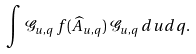Convert formula to latex. <formula><loc_0><loc_0><loc_500><loc_500>\int { \mathcal { G } } _ { u , q } \, f ( { \widehat { A } } _ { u , q } ) \, { \mathcal { G } } _ { u , q } \, d u d q .</formula> 